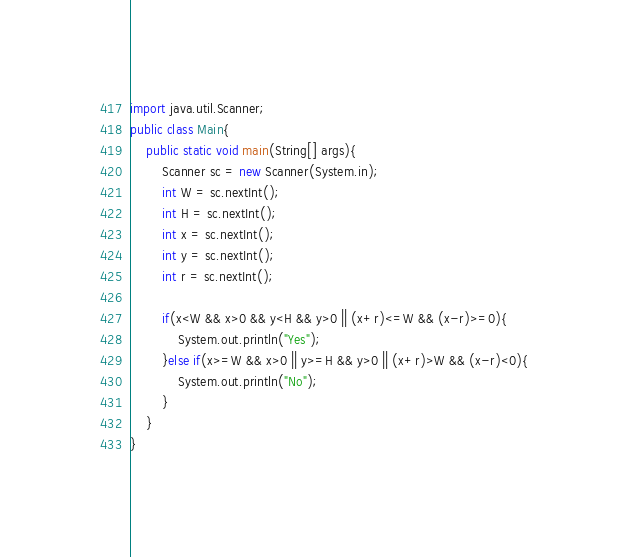<code> <loc_0><loc_0><loc_500><loc_500><_Java_>import java.util.Scanner;
public class Main{
	public static void main(String[] args){
		Scanner sc = new Scanner(System.in);
		int W = sc.nextInt();
		int H = sc.nextInt();
		int x = sc.nextInt();
		int y = sc.nextInt();
		int r = sc.nextInt();
		
		if(x<W && x>0 && y<H && y>0 || (x+r)<=W && (x-r)>=0){
			System.out.println("Yes");
		}else if(x>=W && x>0 || y>=H && y>0 || (x+r)>W && (x-r)<0){
			System.out.println("No");
		}
	}
}</code> 